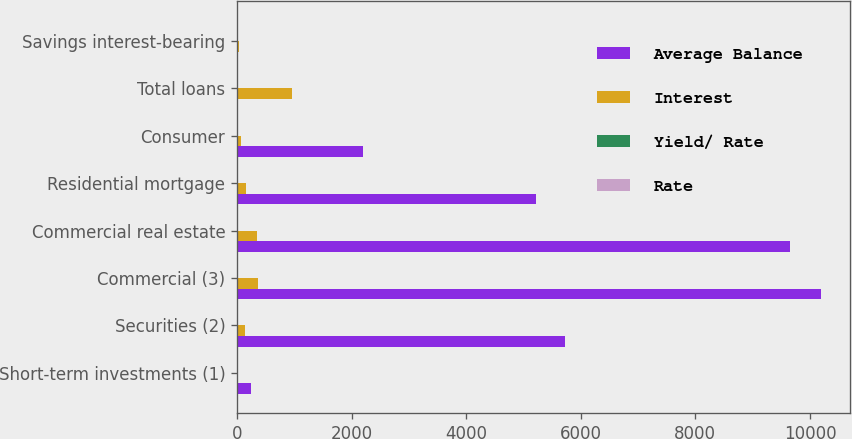Convert chart to OTSL. <chart><loc_0><loc_0><loc_500><loc_500><stacked_bar_chart><ecel><fcel>Short-term investments (1)<fcel>Securities (2)<fcel>Commercial (3)<fcel>Commercial real estate<fcel>Residential mortgage<fcel>Consumer<fcel>Total loans<fcel>Savings interest-bearing<nl><fcel>Average Balance<fcel>247.8<fcel>5731.5<fcel>10189.5<fcel>9643.9<fcel>5222.4<fcel>2193.1<fcel>4.155<fcel>4.155<nl><fcel>Interest<fcel>0.5<fcel>135.7<fcel>375.4<fcel>343.5<fcel>166.7<fcel>72.3<fcel>957.9<fcel>43.5<nl><fcel>Yield/ Rate<fcel>0.2<fcel>2.37<fcel>3.68<fcel>3.56<fcel>3.19<fcel>3.3<fcel>3.52<fcel>0.26<nl><fcel>Rate<fcel>0.22<fcel>2.15<fcel>4.23<fcel>4.41<fcel>3.42<fcel>3.49<fcel>4.08<fcel>0.27<nl></chart> 